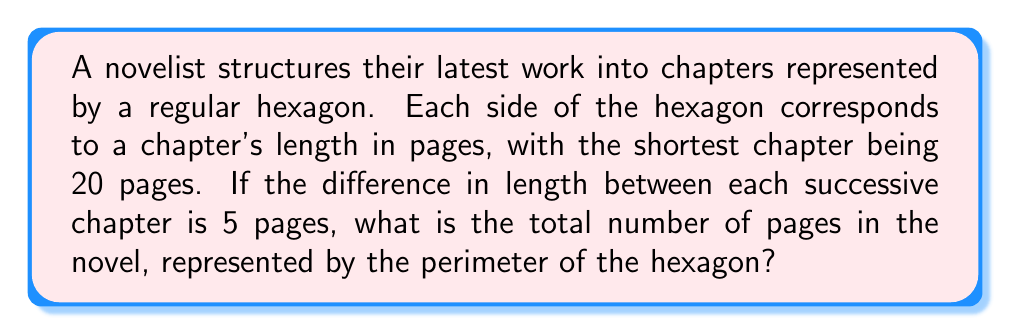Solve this math problem. Let's approach this step-by-step:

1) In a regular hexagon, all sides are equal. However, in this case, each side represents a different chapter length.

2) We're told the shortest chapter is 20 pages and the difference between successive chapters is 5 pages.

3) Let's list out the chapter lengths:
   Chapter 1: 20 pages
   Chapter 2: 25 pages
   Chapter 3: 30 pages
   Chapter 4: 35 pages
   Chapter 5: 40 pages
   Chapter 6: 45 pages

4) To find the perimeter, we need to sum all these lengths:

   $$P = 20 + 25 + 30 + 35 + 40 + 45$$

5) This can be simplified using the arithmetic sequence sum formula:
   $$S_n = \frac{n}{2}(a_1 + a_n)$$
   Where $S_n$ is the sum, $n$ is the number of terms, $a_1$ is the first term, and $a_n$ is the last term.

6) In our case:
   $n = 6$ (six chapters)
   $a_1 = 20$ (first chapter)
   $a_6 = 45$ (last chapter)

7) Plugging into the formula:
   $$P = \frac{6}{2}(20 + 45) = 3(65) = 195$$

Therefore, the perimeter of the hexagon, representing the total number of pages in the novel, is 195 pages.
Answer: 195 pages 